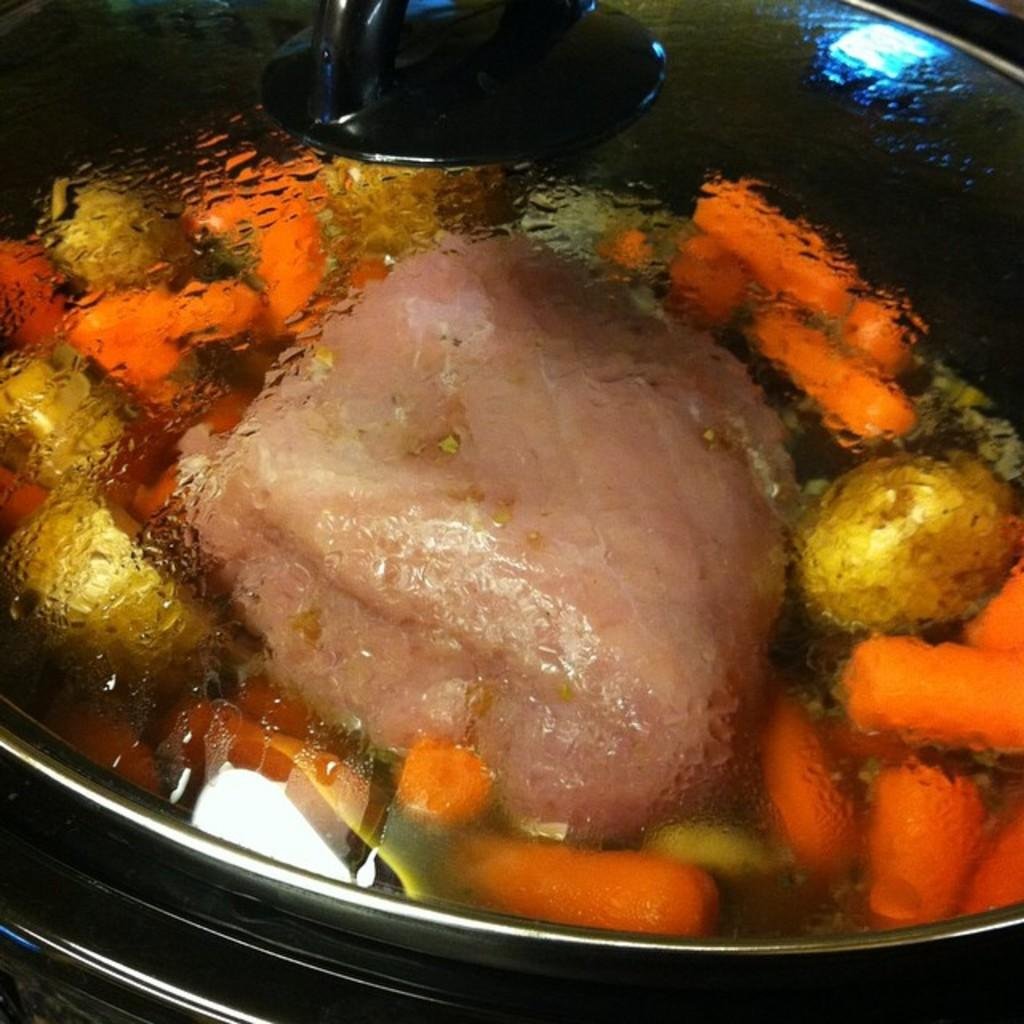What is the main object in the image? There is a pane in the image. What is inside the pane? The pane contains food items. How are the food items contained within the pane? The food items have lids. What type of poison is being used to preserve the food items in the image? There is no mention of poison or any preservation method in the image; the food items have lids to contain them. 